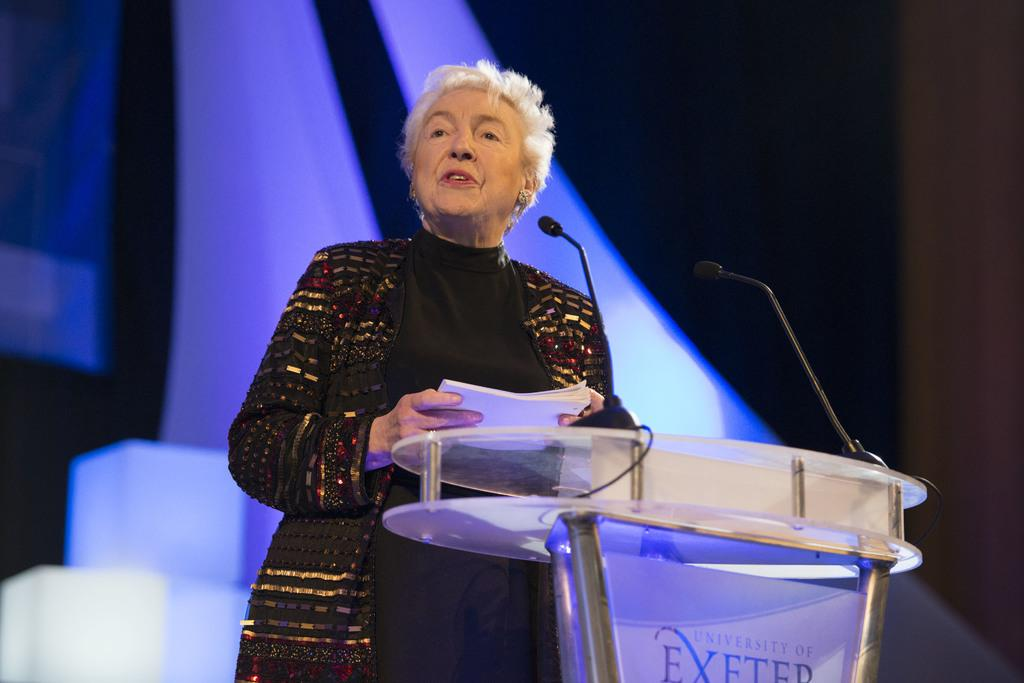What is the main subject of the image? There is a woman in the image. What is the woman doing in the image? The woman is standing and holding papers. What object is present in the image that the woman might be using? There is a glass podium in the image, which the woman might be using. What can be seen on the podium? The podium has mics on it. Can you describe the background of the image? The background of the image is blurry. What type of volleyball game is being played in the background of the image? There is no volleyball game present in the image; the background is blurry. What thrilling activity is the woman participating in, as seen in the image? The image does not depict any thrilling activities; the woman is simply standing and holding papers. 